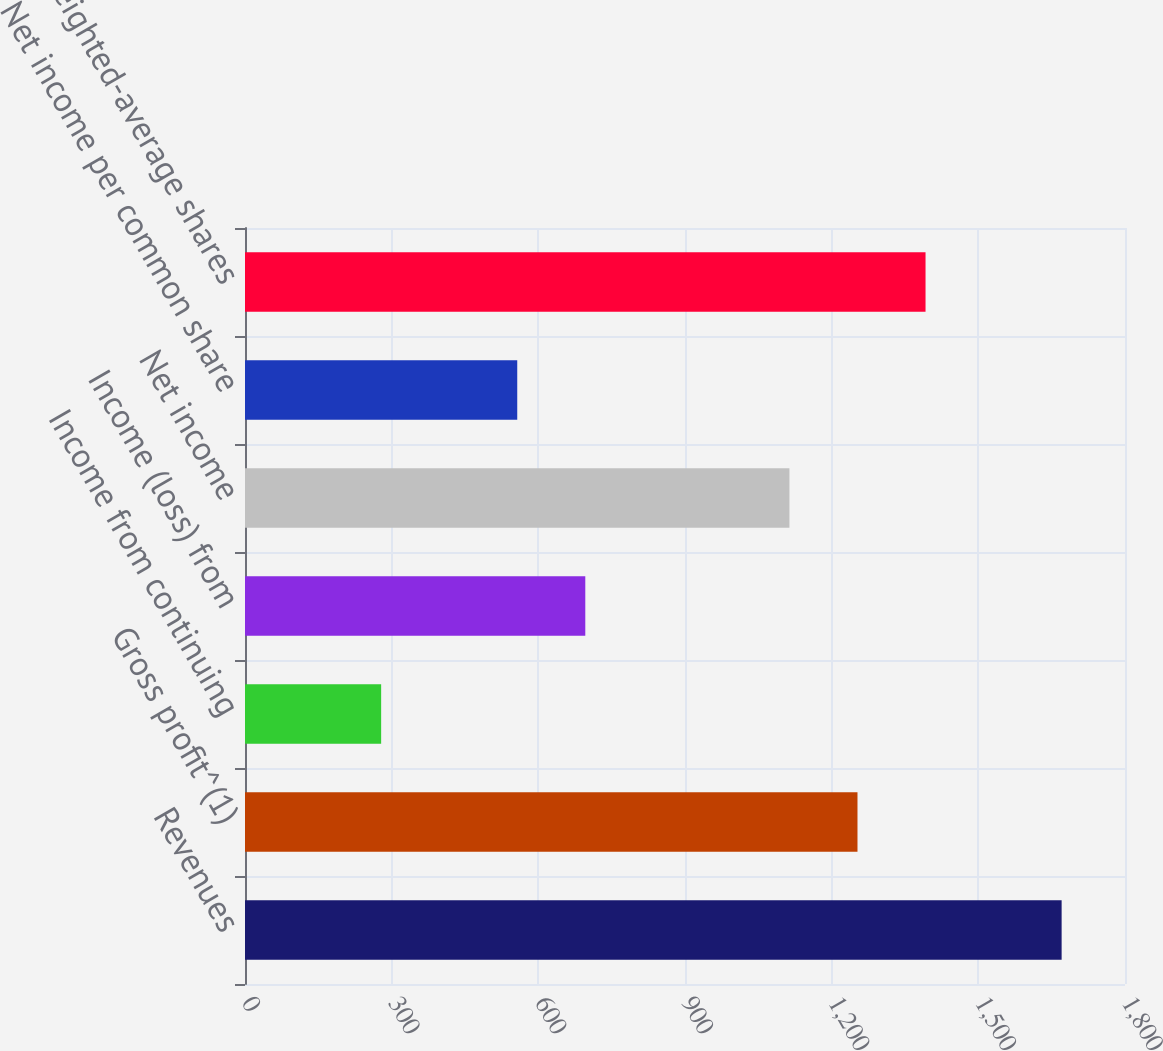Convert chart to OTSL. <chart><loc_0><loc_0><loc_500><loc_500><bar_chart><fcel>Revenues<fcel>Gross profit^(1)<fcel>Income from continuing<fcel>Income (loss) from<fcel>Net income<fcel>Net income per common share<fcel>Basic weighted-average shares<nl><fcel>1670.38<fcel>1252.81<fcel>278.48<fcel>696.05<fcel>1113.62<fcel>556.86<fcel>1392<nl></chart> 